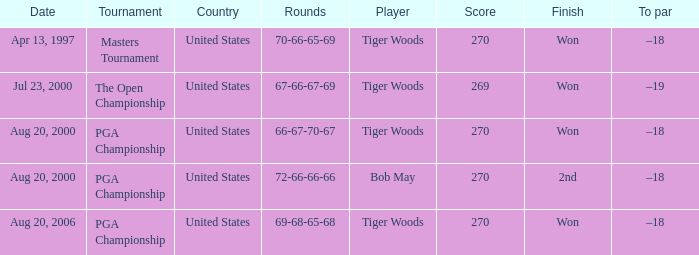What is the worst (highest) score? 270.0. 